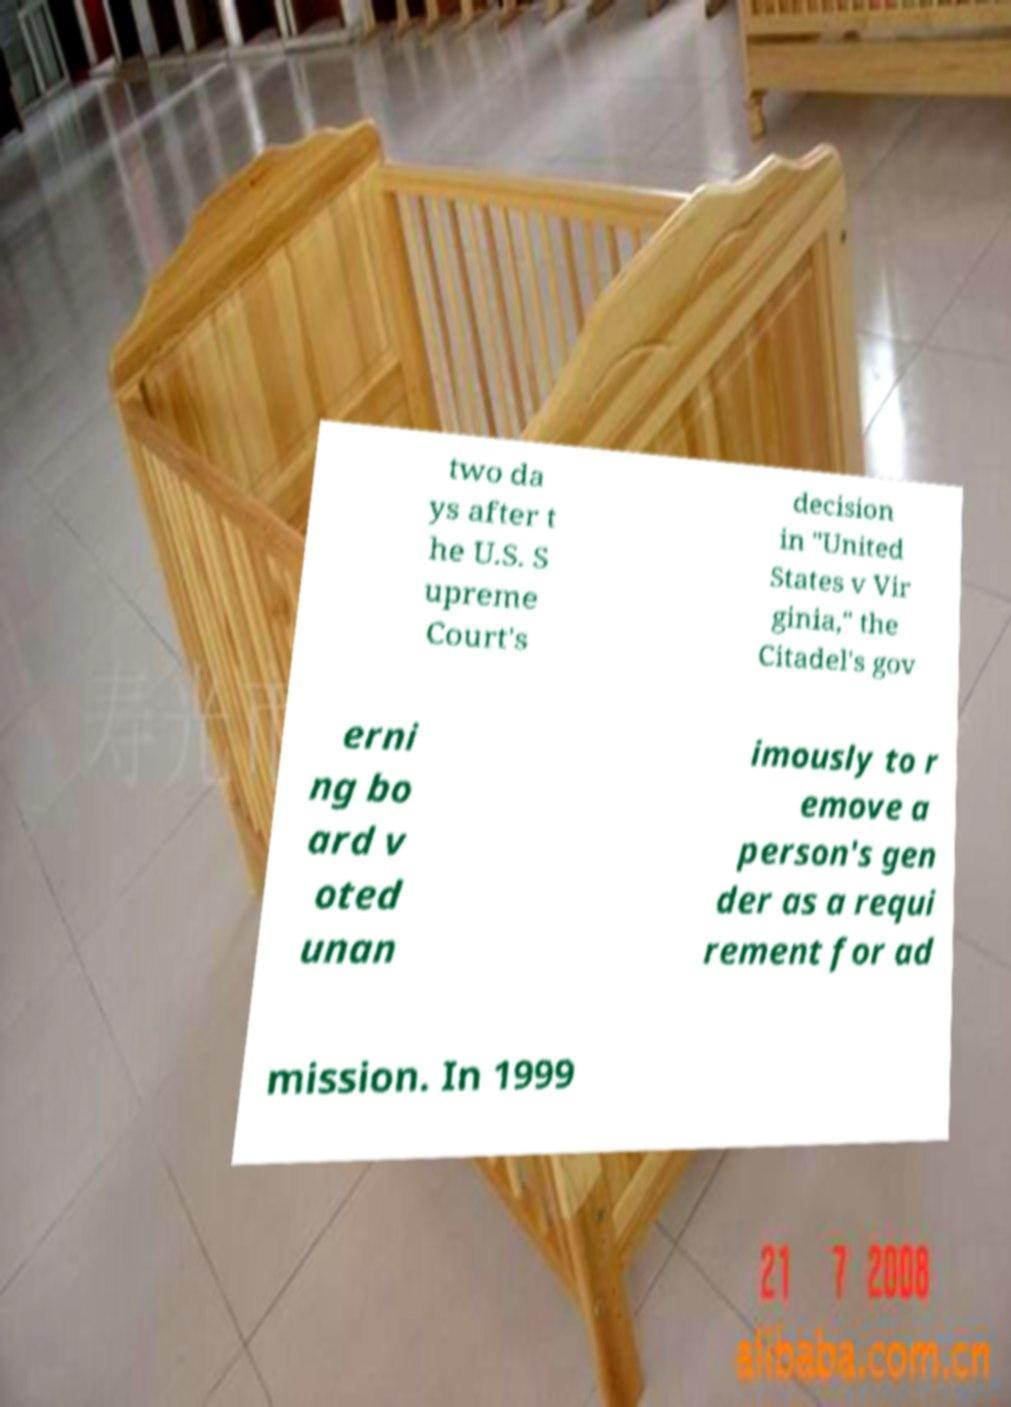There's text embedded in this image that I need extracted. Can you transcribe it verbatim? two da ys after t he U.S. S upreme Court's decision in "United States v Vir ginia," the Citadel's gov erni ng bo ard v oted unan imously to r emove a person's gen der as a requi rement for ad mission. In 1999 